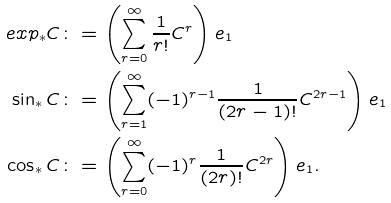Convert formula to latex. <formula><loc_0><loc_0><loc_500><loc_500>e x p _ { * } C & \colon = \left ( \sum _ { r = 0 } ^ { \infty } \frac { 1 } { r ! } C ^ { r } \right ) e _ { 1 } \\ \sin _ { * } C & \colon = \left ( \sum _ { r = 1 } ^ { \infty } ( - 1 ) ^ { r - 1 } \frac { 1 } { ( 2 r - 1 ) ! } C ^ { 2 r - 1 } \right ) e _ { 1 } \\ \cos _ { * } C & \colon = \left ( \sum _ { r = 0 } ^ { \infty } ( - 1 ) ^ { r } \frac { 1 } { ( 2 r ) ! } C ^ { 2 r } \right ) e _ { 1 } .</formula> 